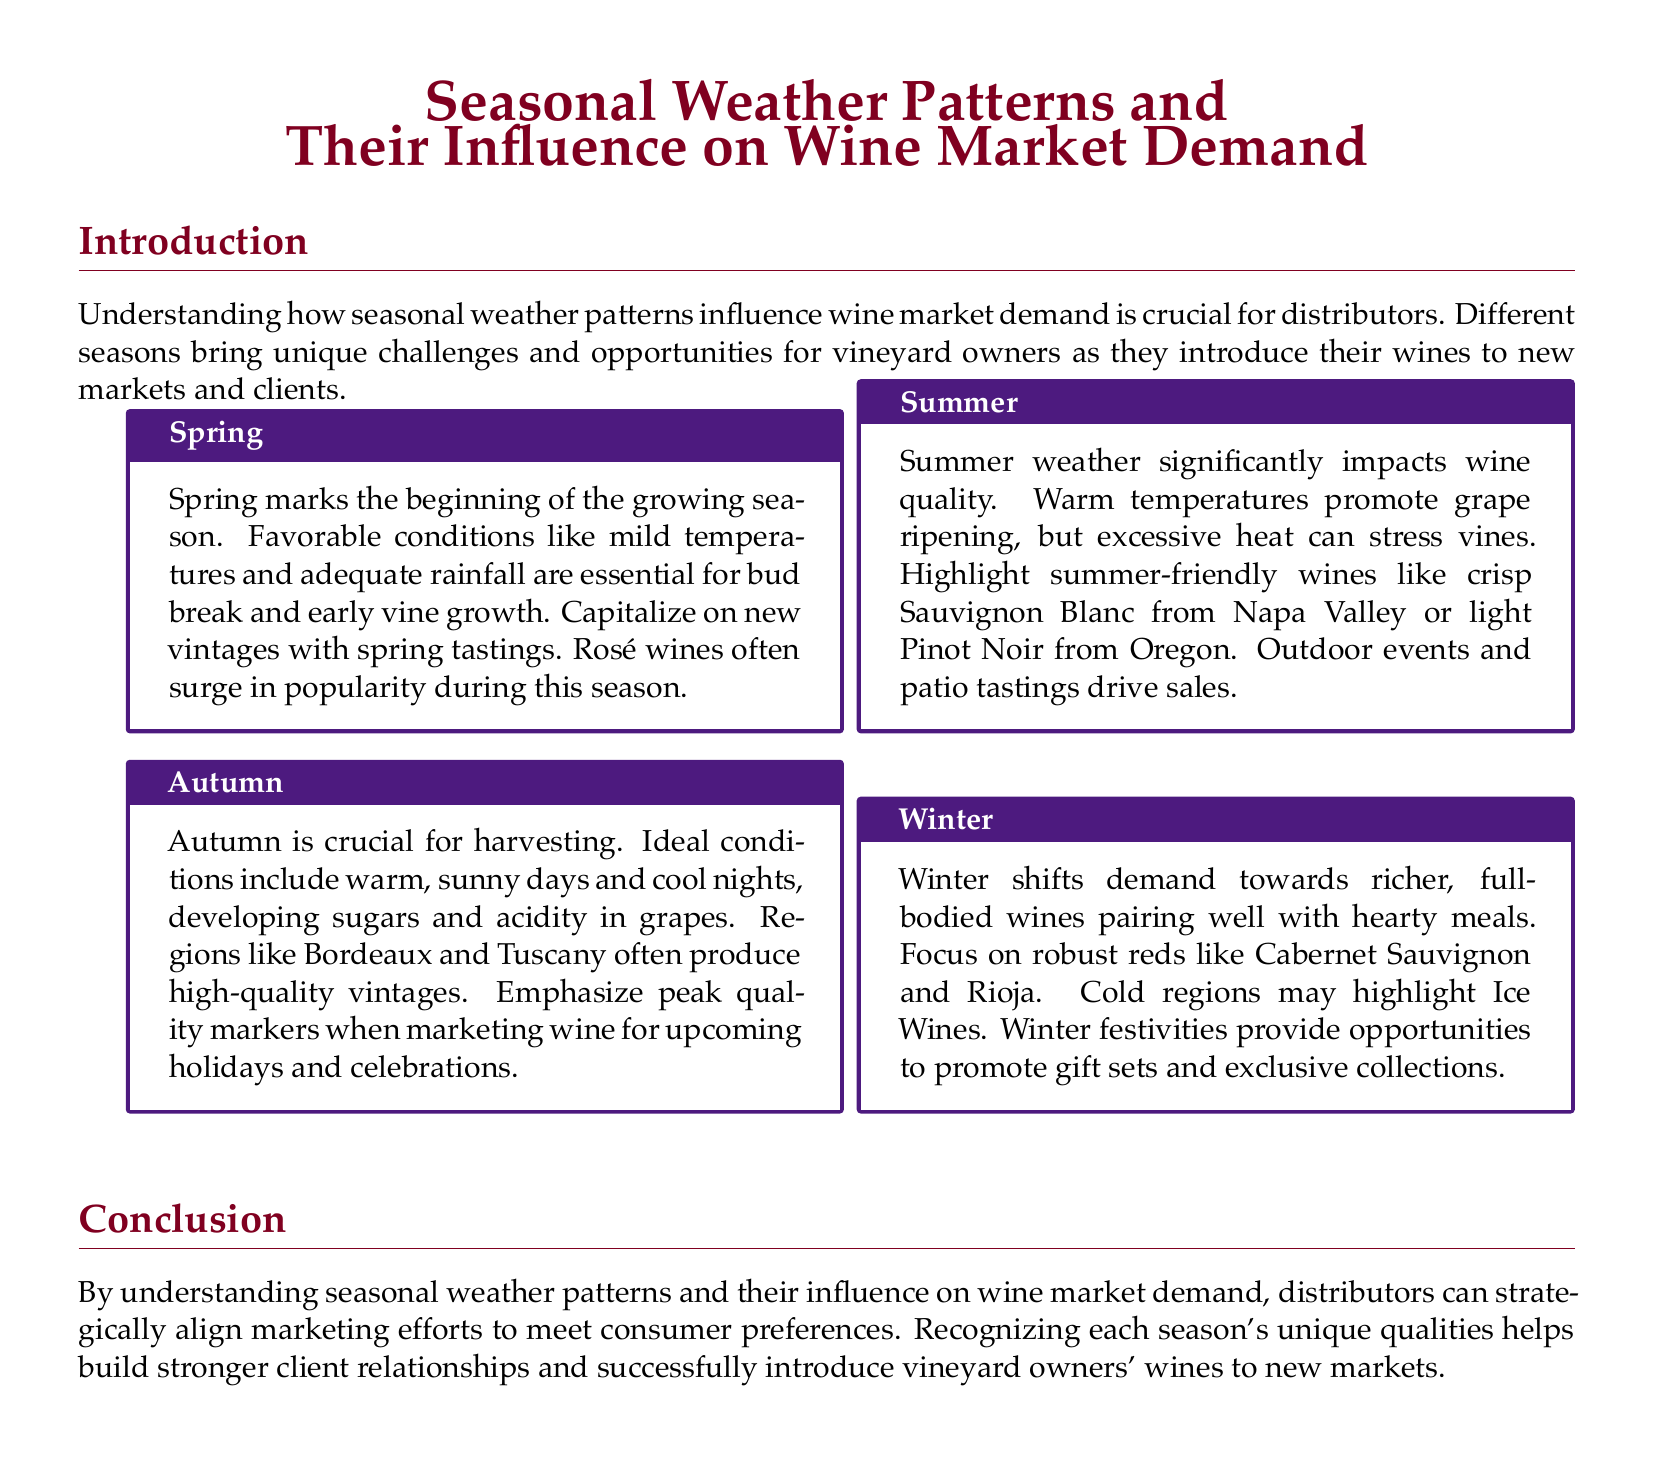What influences the beginning of the growing season? Spring is marked by mild temperatures and adequate rainfall, which are essential for bud break and early vine growth.
Answer: Mild temperatures and adequate rainfall What type of wine often surges in popularity during spring? Spring tastings capitalize on new vintages, where Rosé wines often see increased demand in this season.
Answer: Rosé wines What is a key factor in summer weather affecting wine quality? Warm temperatures promote grape ripening but excessive heat can stress the vines, impacting quality.
Answer: Warm temperatures Which wines are emphasized for winter marketing? During winter, the focus shifts to rich, full-bodied wines that pair well with hearty meals, including robust reds.
Answer: Cabernet Sauvignon and Rioja What is crucial for wine production in autumn? Ideal conditions for autumn include warm, sunny days and cool nights, which develop sugars and acidity in the grapes.
Answer: Warm, sunny days and cool nights How do distributors align their marketing efforts? Understanding seasonal weather patterns helps distributors align their marketing to meet consumer preferences effectively.
Answer: Strategic alignment What type of events drive wine sales in summer? Outdoor events and patio tastings are highlighted as key drivers of wine sales during the summer season.
Answer: Outdoor events and patio tastings What season focuses on promoting gift sets? Winter offers opportunities to promote gift sets and exclusive collections.
Answer: Winter Which regions are noted for high-quality vintages in autumn? Regions mentioned for producing high-quality vintages during autumn include Bordeaux and Tuscany.
Answer: Bordeaux and Tuscany 